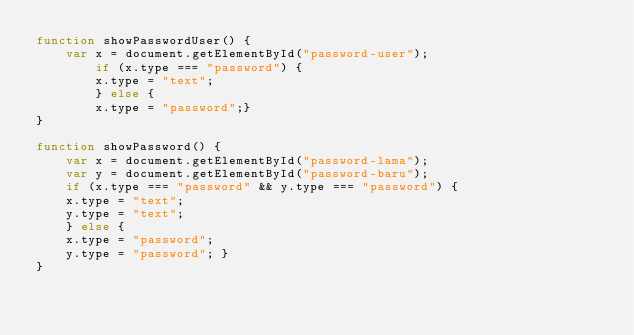Convert code to text. <code><loc_0><loc_0><loc_500><loc_500><_JavaScript_>function showPasswordUser() {
    var x = document.getElementById("password-user");
        if (x.type === "password") {
        x.type = "text";
        } else {
        x.type = "password";}
}

function showPassword() {
    var x = document.getElementById("password-lama");
    var y = document.getElementById("password-baru");
    if (x.type === "password" && y.type === "password") {
    x.type = "text";
    y.type = "text";
    } else {
    x.type = "password";
    y.type = "password"; }
}
</code> 